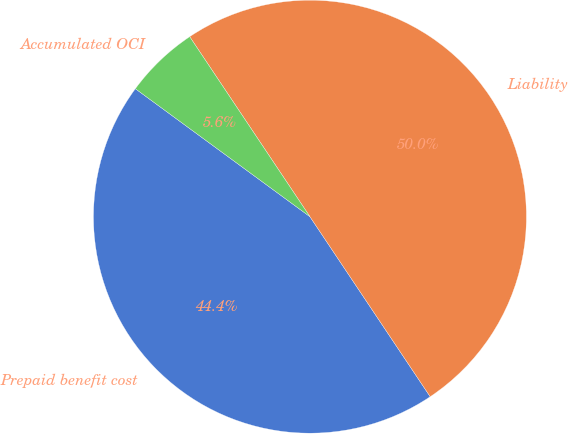Convert chart. <chart><loc_0><loc_0><loc_500><loc_500><pie_chart><fcel>Prepaid benefit cost<fcel>Liability<fcel>Accumulated OCI<nl><fcel>44.44%<fcel>50.0%<fcel>5.56%<nl></chart> 